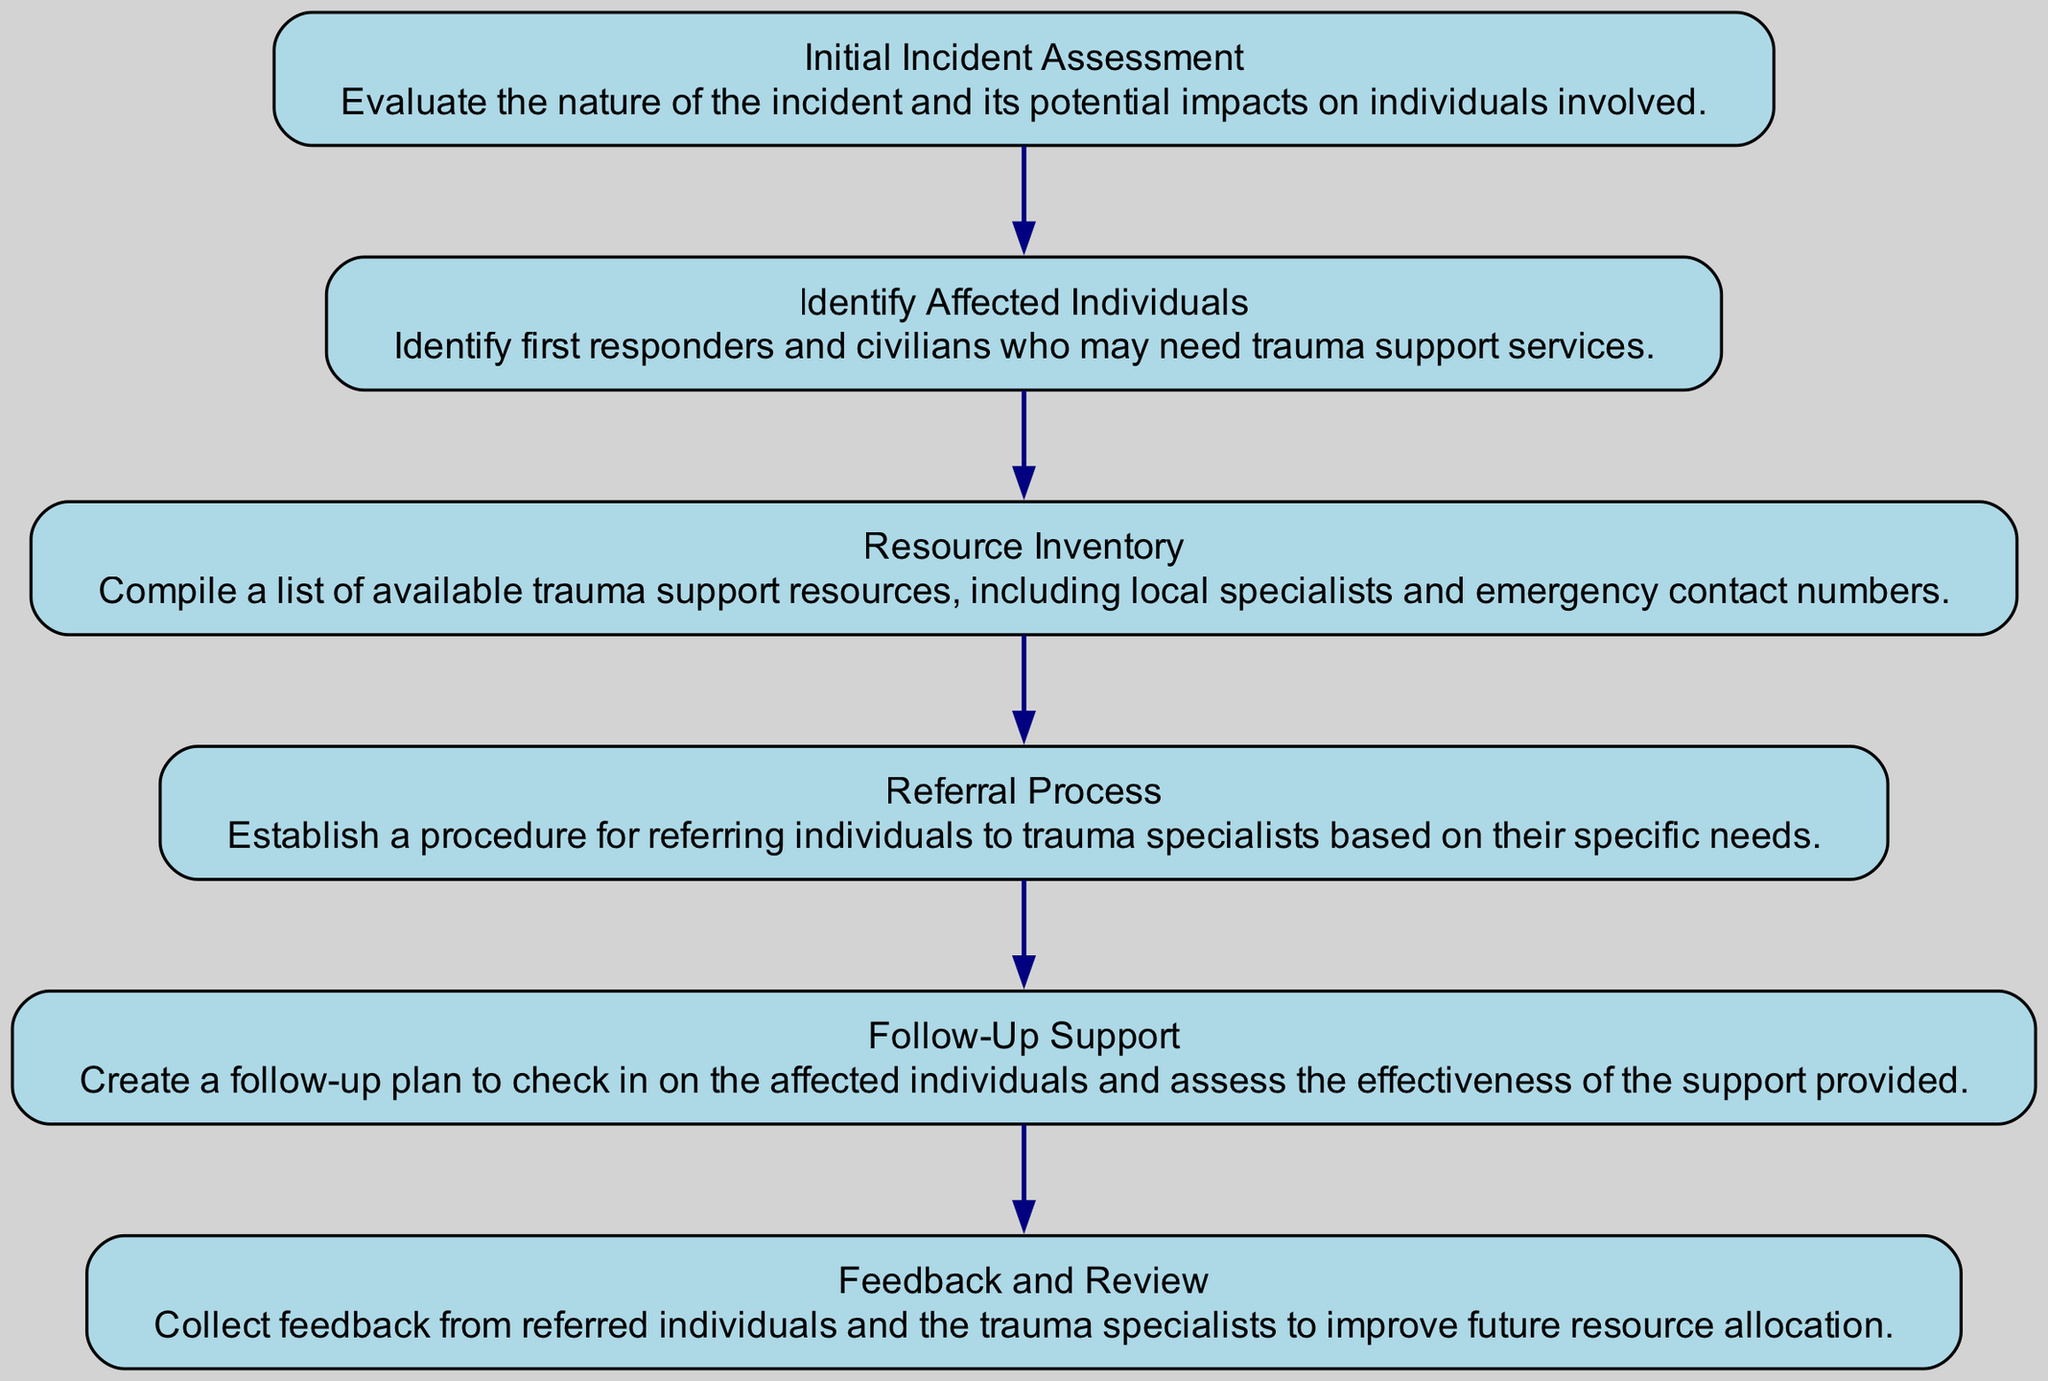What is the first step in the resource allocation process? The diagram shows that the first step in the resource allocation for trauma support services is the "Initial Incident Assessment." This is the starting node from which all other processes flow.
Answer: Initial Incident Assessment How many total nodes are present in the diagram? By counting the elements listed in the diagram, there are six nodes representing different stages in the resource allocation process.
Answer: 6 What is the last step in the flow of the diagram? The last step indicated in the flow chart is "Feedback and Review." This node is positioned at the end of the flow, suggesting it is the final stage after all prior steps have been completed.
Answer: Feedback and Review Which node directly follows "Resource Inventory"? According to the flow structure depicted in the diagram, the node that follows "Resource Inventory" is "Referral Process." This can be determined by tracing the directed edge from "Resource Inventory."
Answer: Referral Process What is the main purpose of the "Follow-Up Support" node? The description of the "Follow-Up Support" node states that its purpose is to create a plan for checking in on affected individuals and assessing the effectiveness of the support provided.
Answer: Assess effectiveness What is the relationship between "Identify Affected Individuals" and "Resource Inventory"? The relationship is sequential; "Identify Affected Individuals" leads to "Resource Inventory." The flow chart indicates that once the affected individuals have been identified, the next step involves compiling a list of available resources.
Answer: Sequential What should be collected according to the "Feedback and Review" step? The "Feedback and Review" node indicates that feedback should be collected from referred individuals and trauma specialists. This information is essential for improving future resource efforts.
Answer: Feedback Which step involves establishing a procedure for referrals? The diagram specifically outlines that the "Referral Process" node is the one responsible for establishing a procedure for referring individuals to trauma specialists based on their needs.
Answer: Referral Process 